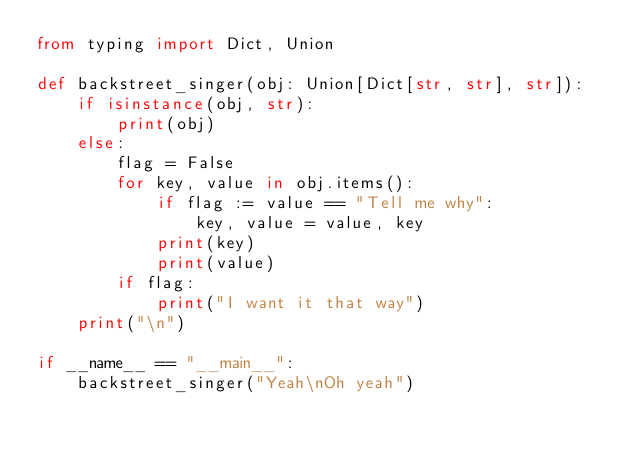<code> <loc_0><loc_0><loc_500><loc_500><_Python_>from typing import Dict, Union

def backstreet_singer(obj: Union[Dict[str, str], str]):
    if isinstance(obj, str):
        print(obj)
    else:
        flag = False
        for key, value in obj.items():
            if flag := value == "Tell me why":
                key, value = value, key
            print(key)
            print(value)
        if flag:
            print("I want it that way")
    print("\n")

if __name__ == "__main__":
    backstreet_singer("Yeah\nOh yeah")</code> 